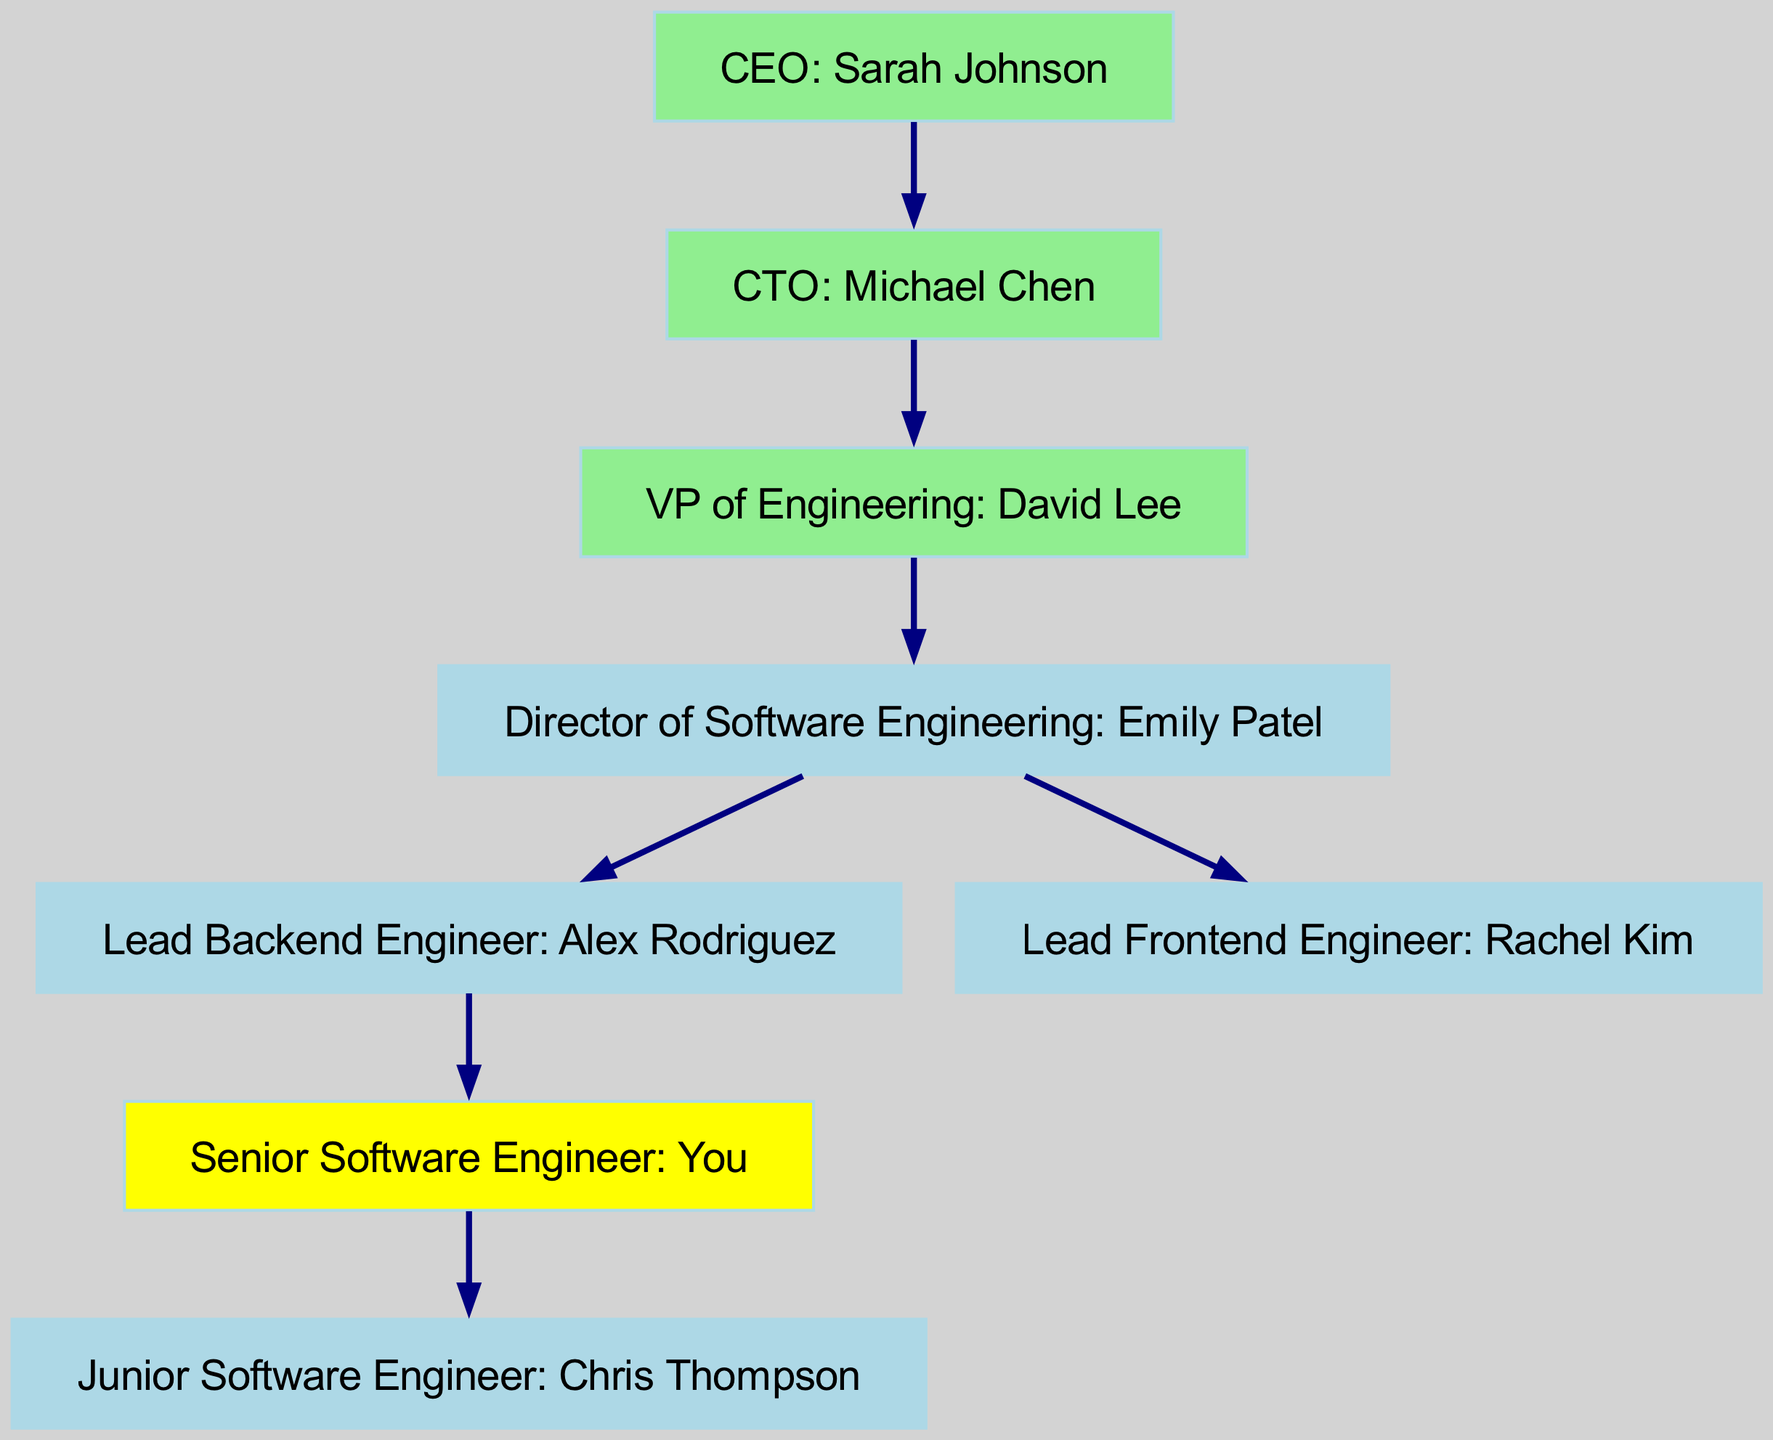What is the role of the top-level node? The top-level node is the CEO, indicating the highest position in the organization, responsible for overall management.
Answer: CEO: Sarah Johnson How many nodes are in the diagram? To find the total number of nodes, count each distinct position listed in the data: CEO, CTO, VP of Engineering, Director of Software Engineering, Lead Backend Engineer, Lead Frontend Engineer, Senior Software Engineer, and Junior Software Engineer. This totals to eight nodes.
Answer: 8 Who reports directly to the CTO? The node that connects directly to the CTO in the hierarchy is the VP of Engineering. This can be identified by checking the edges from the CTO's node.
Answer: VP of Engineering: David Lee What color is the Senior Software Engineer node? The Senior Software Engineer node is filled with yellow, which is specifically designated in the diagram for that position.
Answer: Yellow Which position is in charge of the backend team? The position that oversees the backend team, as shown by the direct edge from the Director of Software Engineering, is the Lead Backend Engineer.
Answer: Lead Backend Engineer: Alex Rodriguez Who are the immediate subordinates of the Director of Software Engineering? To determine the immediate subordinates of the Director of Software Engineering, look for nodes that have directed edges from this director node. They are the Lead Backend Engineer and Lead Frontend Engineer.
Answer: Lead Backend Engineer and Lead Frontend Engineer How many edges are present in the diagram? Count the connections (or edges) between the nodes listed in the data. There are a total of seven connecting edges in the structure.
Answer: 7 Which node has the highest level of responsibility? The highest node in any hierarchy typically represents the role with the most authority. In this case, it is the CEO, who oversees the entire company structure.
Answer: CEO: Sarah Johnson Which role is immediately below the VP of Engineering? The role directly reporting to the VP of Engineering, as shown by the edge, is the Director of Software Engineering. This indicates the direct line of reporting within the hierarchy.
Answer: Director of Software Engineering: Emily Patel 